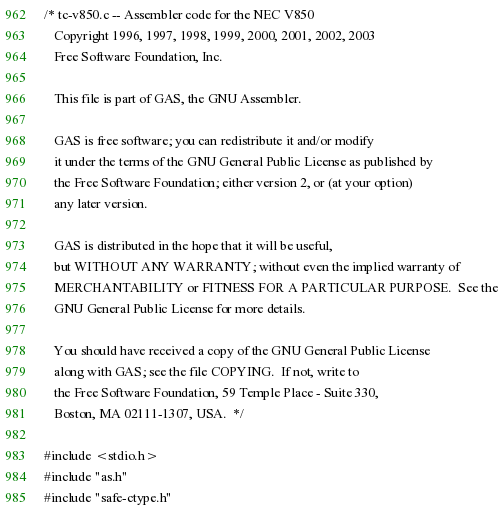<code> <loc_0><loc_0><loc_500><loc_500><_C_>/* tc-v850.c -- Assembler code for the NEC V850
   Copyright 1996, 1997, 1998, 1999, 2000, 2001, 2002, 2003
   Free Software Foundation, Inc.

   This file is part of GAS, the GNU Assembler.

   GAS is free software; you can redistribute it and/or modify
   it under the terms of the GNU General Public License as published by
   the Free Software Foundation; either version 2, or (at your option)
   any later version.

   GAS is distributed in the hope that it will be useful,
   but WITHOUT ANY WARRANTY; without even the implied warranty of
   MERCHANTABILITY or FITNESS FOR A PARTICULAR PURPOSE.  See the
   GNU General Public License for more details.

   You should have received a copy of the GNU General Public License
   along with GAS; see the file COPYING.  If not, write to
   the Free Software Foundation, 59 Temple Place - Suite 330,
   Boston, MA 02111-1307, USA.  */

#include <stdio.h>
#include "as.h"
#include "safe-ctype.h"</code> 